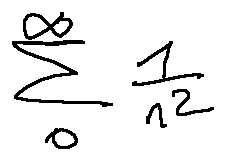Convert formula to latex. <formula><loc_0><loc_0><loc_500><loc_500>\sum \lim i t s _ { 0 } ^ { \infty } \frac { 1 } { n ^ { 2 } }</formula> 